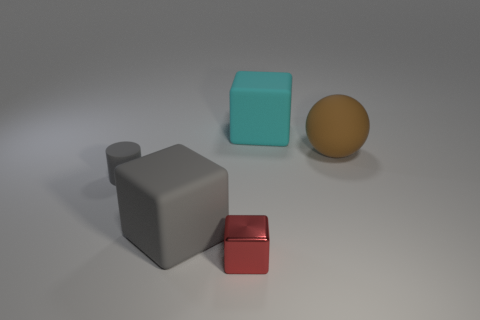Add 4 big gray balls. How many objects exist? 9 Subtract all gray blocks. How many blocks are left? 2 Subtract all cyan blocks. How many blocks are left? 2 Subtract 1 balls. How many balls are left? 0 Subtract all cylinders. How many objects are left? 4 Subtract all cyan cubes. Subtract all green balls. How many cubes are left? 2 Subtract all yellow cylinders. How many cyan spheres are left? 0 Subtract all purple matte things. Subtract all matte objects. How many objects are left? 1 Add 4 large brown objects. How many large brown objects are left? 5 Add 1 big green metal blocks. How many big green metal blocks exist? 1 